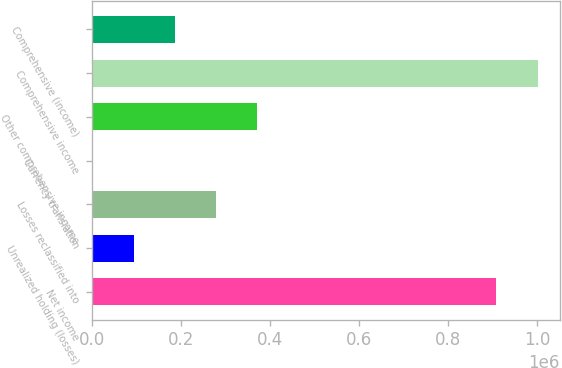Convert chart. <chart><loc_0><loc_0><loc_500><loc_500><bar_chart><fcel>Net income<fcel>Unrealized holding (losses)<fcel>Losses reclassified into<fcel>Currency translation<fcel>Other comprehensive income<fcel>Comprehensive income<fcel>Comprehensive (income)<nl><fcel>908018<fcel>93109.7<fcel>278675<fcel>327<fcel>371458<fcel>1.0008e+06<fcel>185892<nl></chart> 